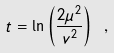<formula> <loc_0><loc_0><loc_500><loc_500>t = \ln \left ( \frac { 2 \mu ^ { 2 } } { v ^ { 2 } } \right ) \ ,</formula> 